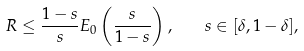<formula> <loc_0><loc_0><loc_500><loc_500>R \leq \frac { 1 - s } { s } E _ { 0 } \left ( \frac { s } { 1 - s } \right ) , \quad s \in [ \delta , 1 - \delta ] ,</formula> 